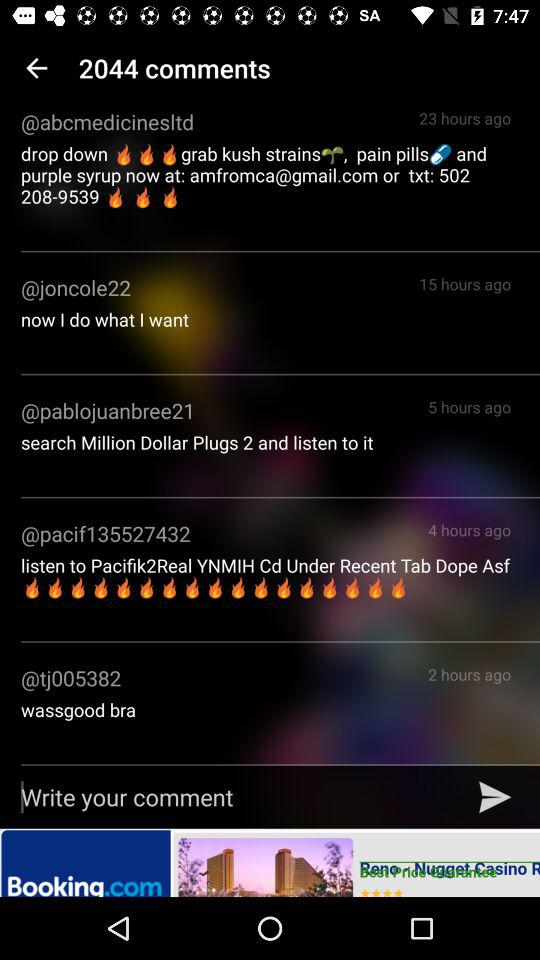How many comments are on this post?
Answer the question using a single word or phrase. 2044 